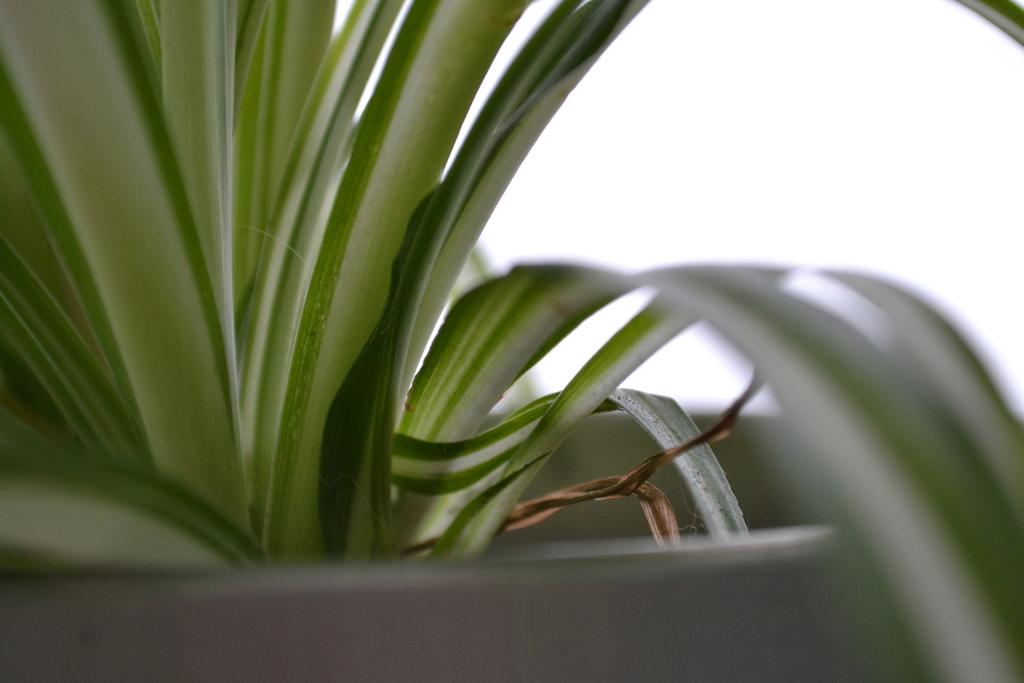What type of plant material is visible in the image? There are leaves of a plant in the image. What is the plant contained in? There is a plant pot in the image. What color is the plant pot? The plant pot is white in color. What type of guide is present in the image? There is no guide present in the image; it features plant leaves and a white plant pot. How many nails can be seen in the image? There are no nails visible in the image. 